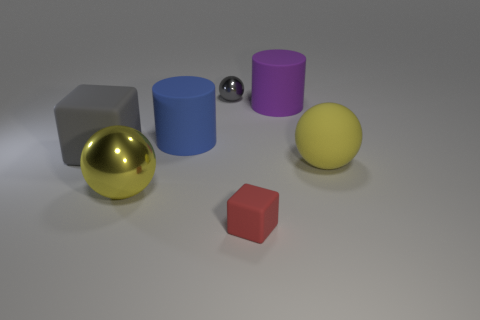Subtract all yellow balls. How many balls are left? 1 Add 2 purple matte objects. How many objects exist? 9 Subtract all purple cylinders. How many cylinders are left? 1 Subtract 1 cubes. How many cubes are left? 1 Add 2 large matte blocks. How many large matte blocks are left? 3 Add 4 tiny matte objects. How many tiny matte objects exist? 5 Subtract 0 red spheres. How many objects are left? 7 Subtract all blocks. How many objects are left? 5 Subtract all blue spheres. Subtract all brown cubes. How many spheres are left? 3 Subtract all blue cylinders. How many gray blocks are left? 1 